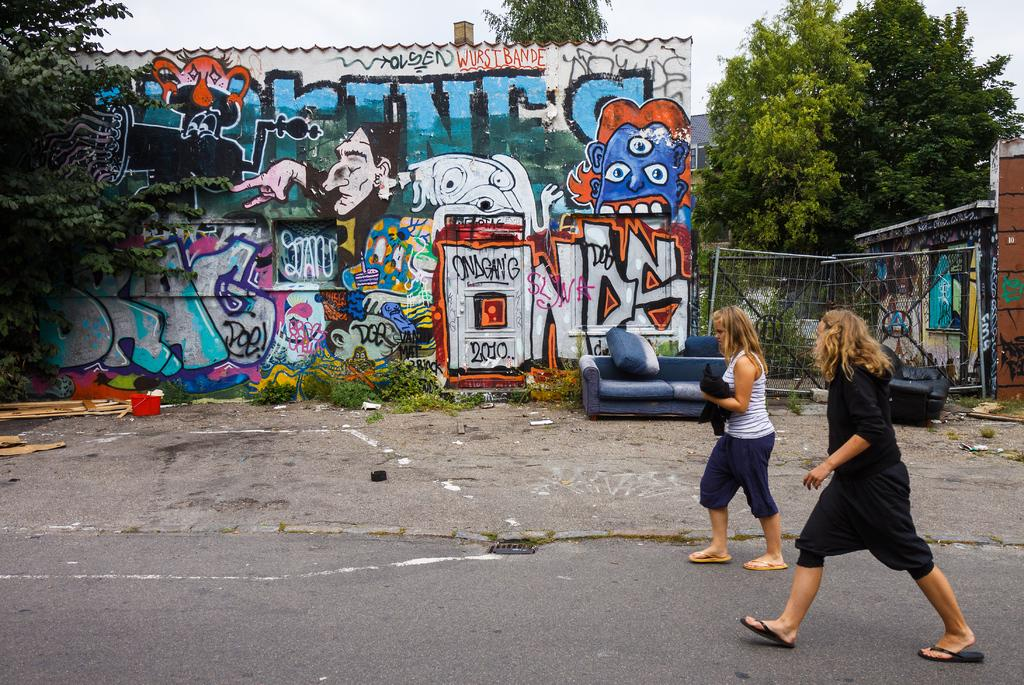How many people are in the image? There are two women in the image. What are the women doing in the image? The women are walking on a road in the image. What can be seen in the background of the image? There is a wall with a painting, trees, a gate, a sofa, and the sky visible in the background. What channel do the women watch on the sofa in the image? There is no sofa present in the image; it is in the background. Additionally, there is no information about the women watching a channel. 